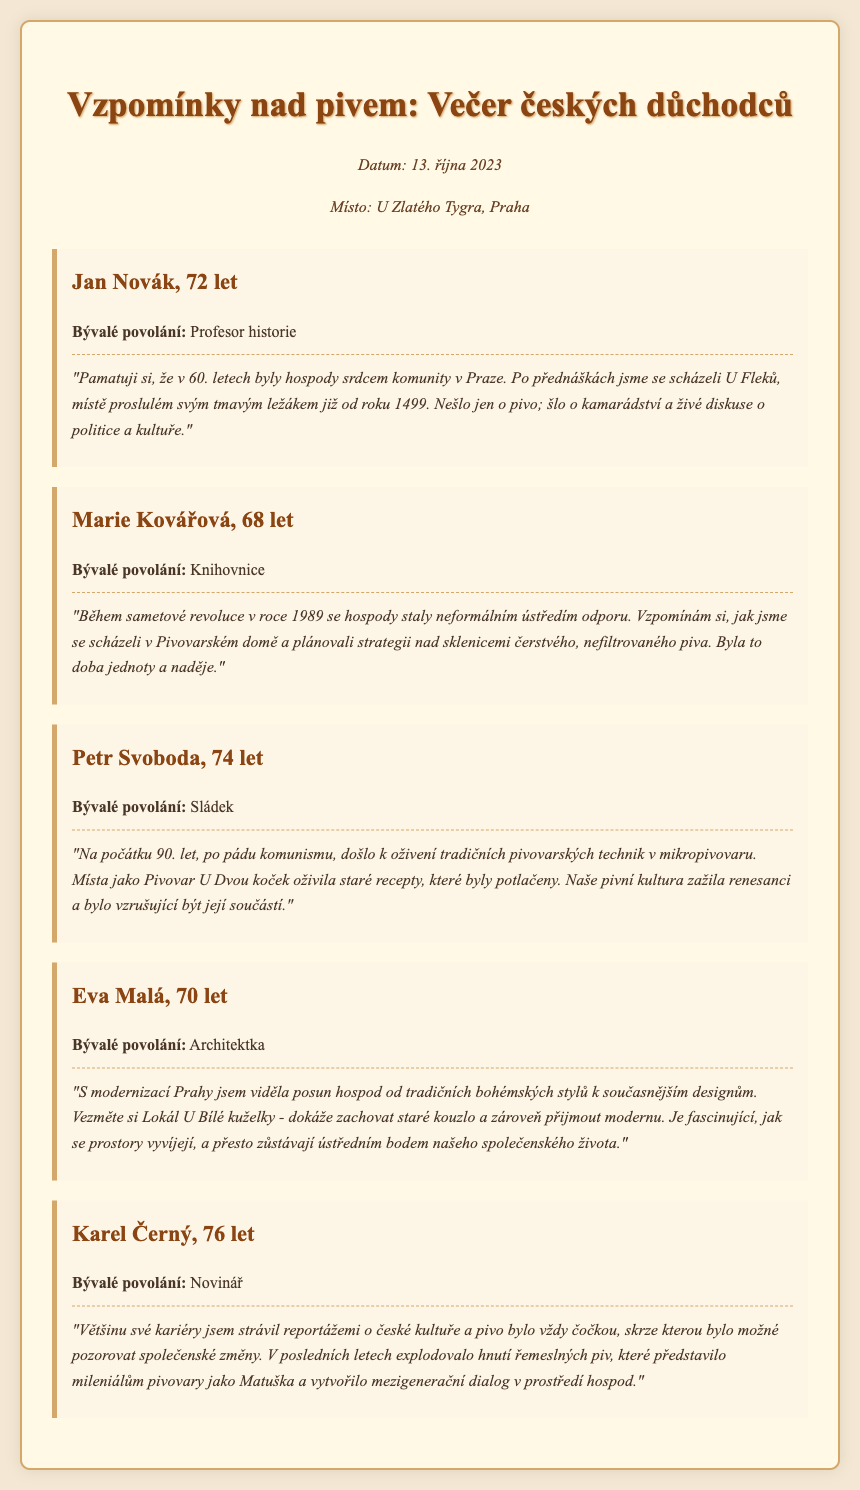What is the date of the event? The date of the event is mentioned in the document as occurring on October 13, 2023.
Answer: October 13, 2023 Where did the event take place? The location of the event is specified as U Zlatého Tygra, which is in Prague.
Answer: U Zlatého Tygra, Praha Who shared memories of the 60s? Jan Novák is the participant who shared memories from the 1960s.
Answer: Jan Novák What profession did Marie Kovářová have? The document states that Marie Kovářová was a librarian.
Answer: Knihovnice Which participant mentioned a revival of traditional brewing techniques? Petr Svoboda discussed the revival of traditional brewing techniques.
Answer: Petr Svoboda What type of beer was famously associated with U Fleků? The well-known type of beer associated with U Fleků is a dark lager.
Answer: tmavým ležákem What significant historical event did Marie Kovářová reference? Marie Kovářová referenced the Velvet Revolution of 1989.
Answer: sametové revoluce What trend did Karel Černý discuss in the document? Karel Černý discussed the explosion of craft beer movements in recent years.
Answer: hnutí řemeslných piv How did Eva Malá describe the change in pubs? Eva Malá described the shift from traditional styles to contemporary designs in pubs.
Answer: posun hospod od tradičních bohémských stylů k současnějším designům 